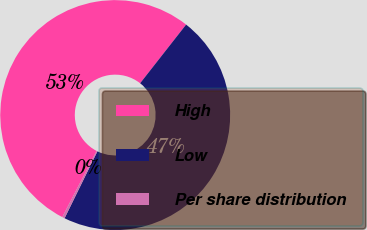<chart> <loc_0><loc_0><loc_500><loc_500><pie_chart><fcel>High<fcel>Low<fcel>Per share distribution<nl><fcel>52.97%<fcel>46.68%<fcel>0.35%<nl></chart> 